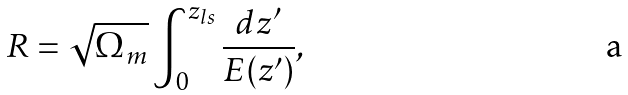Convert formula to latex. <formula><loc_0><loc_0><loc_500><loc_500>R = \sqrt { \Omega _ { m } } \int _ { 0 } ^ { z _ { l s } } \frac { d z ^ { \prime } } { E ( z ^ { \prime } ) } ,</formula> 